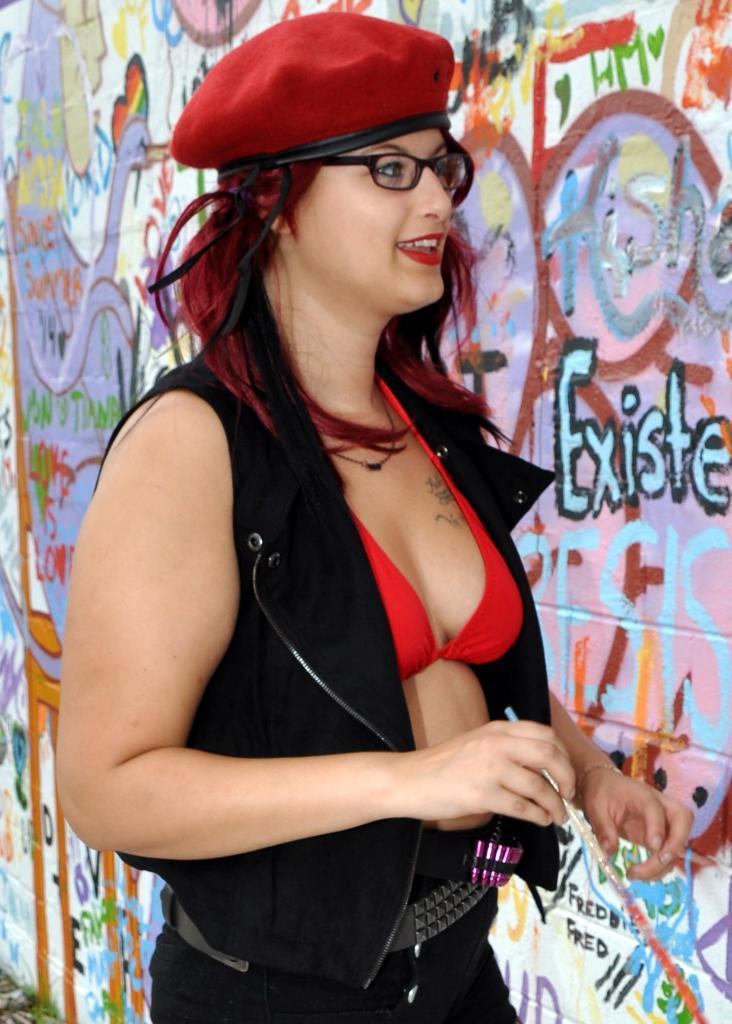Who or what is the main subject in the image? There is a person in the image. Can you describe the person's position in relation to the image? The person is in front. What can be seen behind the person? There is a wall behind the person. How many tickets are visible in the image? There are no tickets present in the image. Is there a knot tied on the wall behind the person? There is no knot visible on the wall behind the person in the image. 